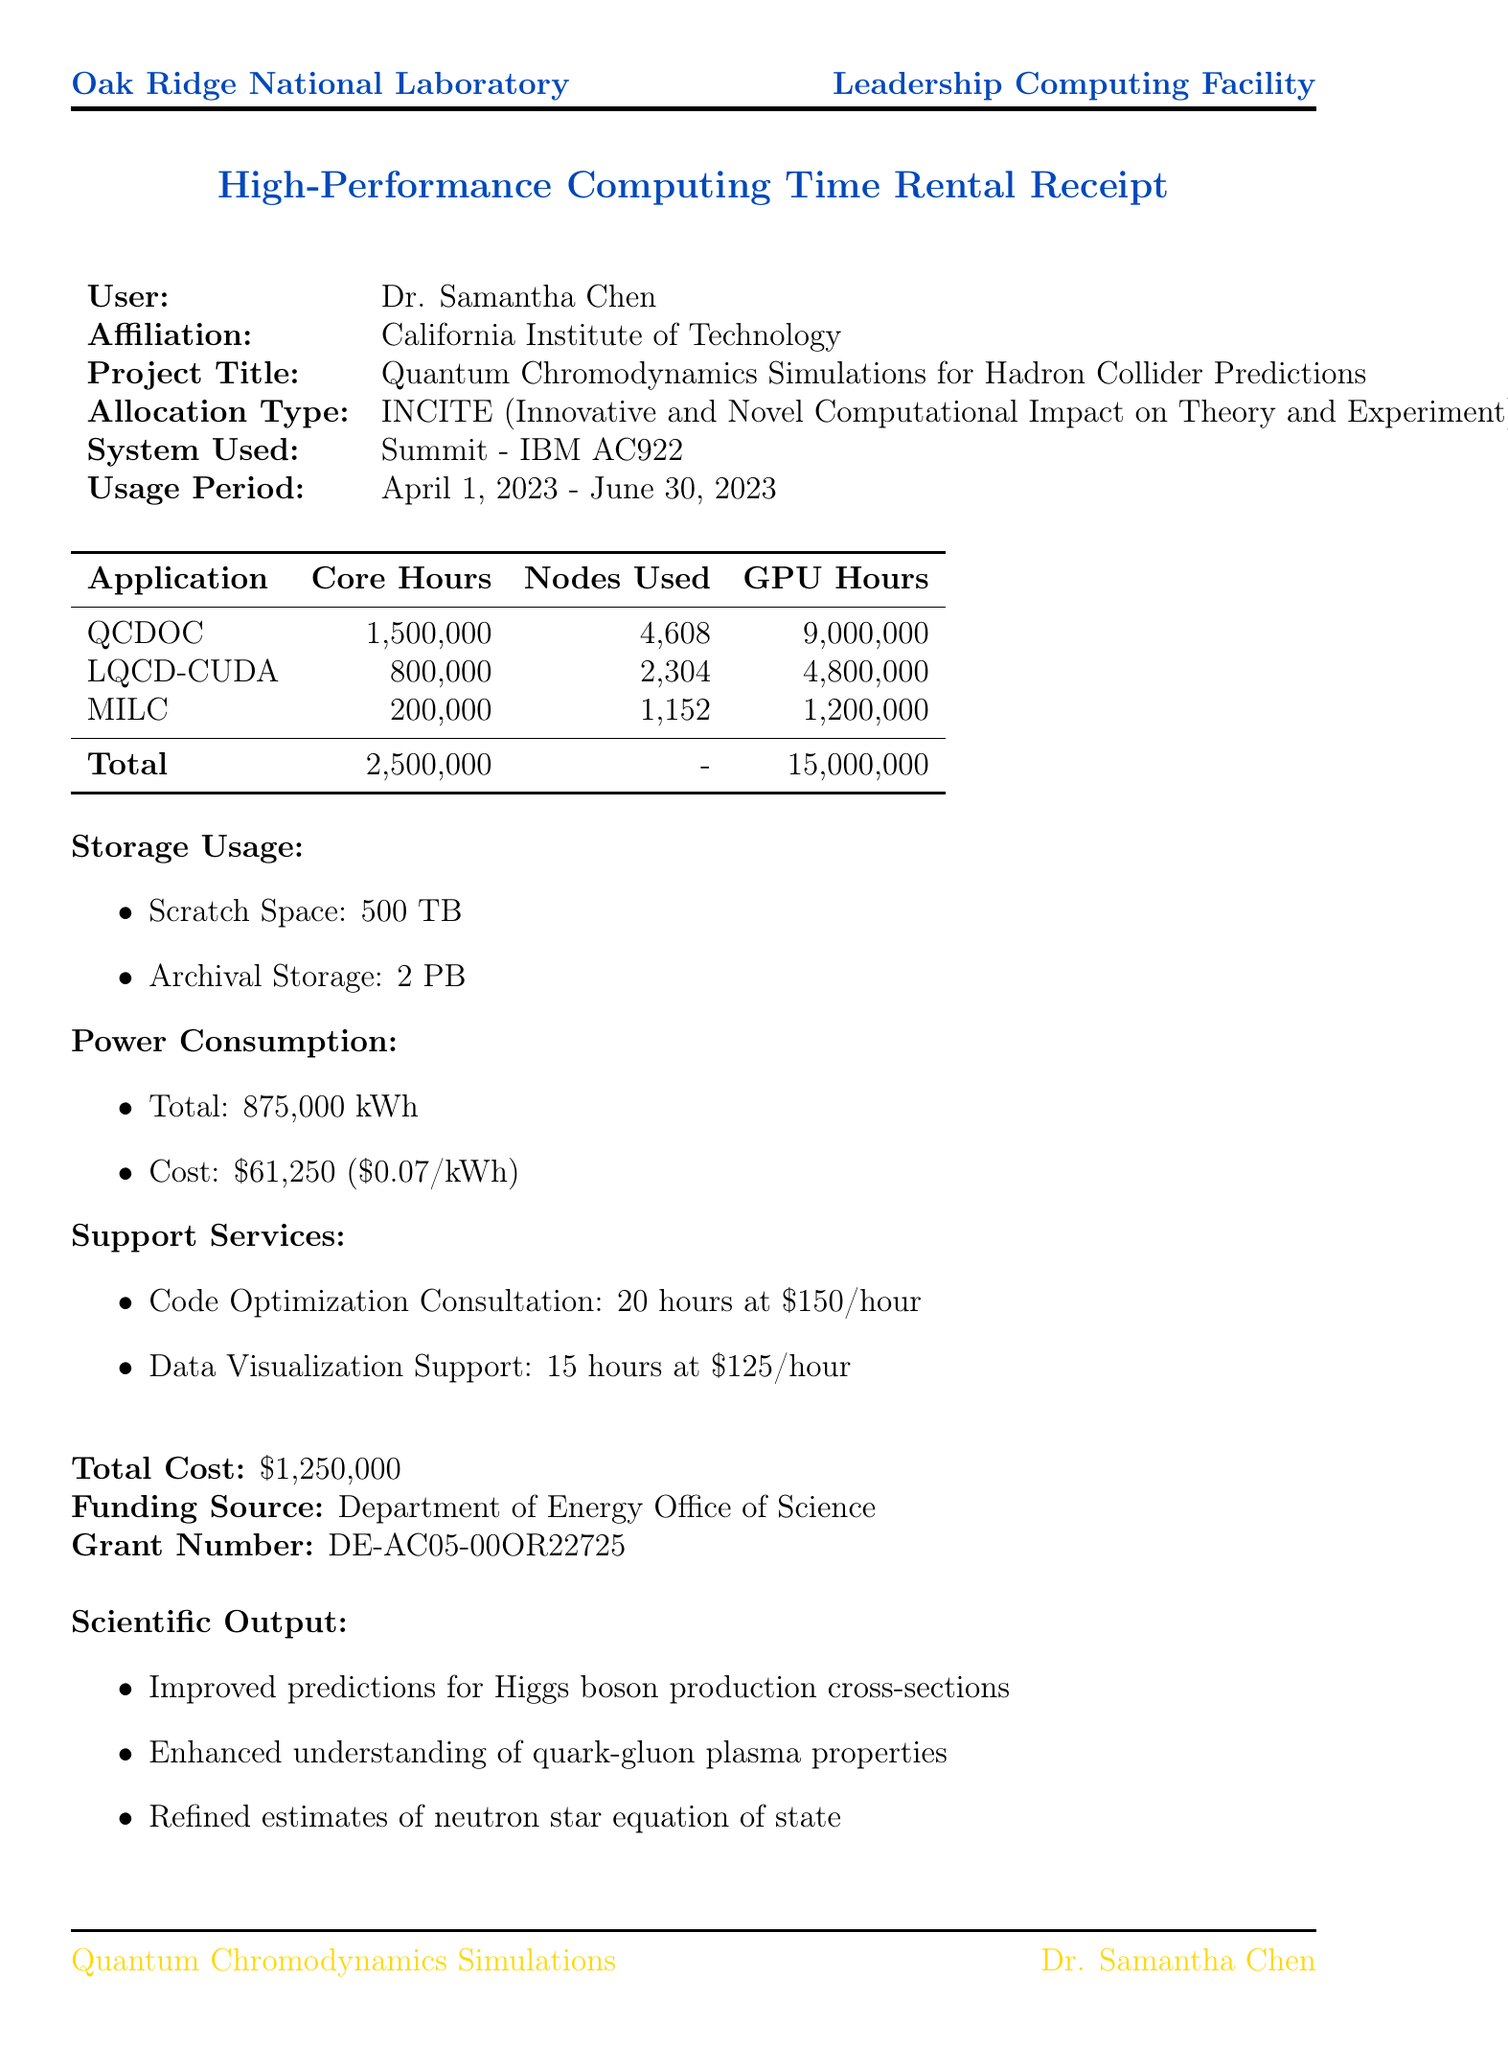What is the user's name? The user's name is stated clearly at the top of the document.
Answer: Dr. Samantha Chen What is the total power cost? The total power cost can be found in the power consumption section of the document.
Answer: $61,250 What is the allocation type of the project? The allocation type is specified in the project details section of the document.
Answer: INCITE (Innovative and Novel Computational Impact on Theory and Experiment) How many GPU hours were used for QCDOC? The GPU hours used for QCDOC are listed in the breakdown of application usage.
Answer: 9,000,000 What is the total number of core hours used? The total number of core hours is summarily presented in the application usage section.
Answer: 2,500,000 What scientific output relates to Higgs boson? The scientific output sections provide specific results achieved through the research.
Answer: Improved predictions for Higgs boson production cross-sections How much scratch space was used? The document explicitly states the amount of scratch space utilized in the storage usage section.
Answer: 500 TB What service was charged at $150 per hour? The support services section outlines the various services and their rates.
Answer: Code Optimization Consultation In which facility was the computing time rented? The facility name is mentioned prominently at the top of the receipt.
Answer: Oak Ridge National Laboratory Leadership Computing Facility 